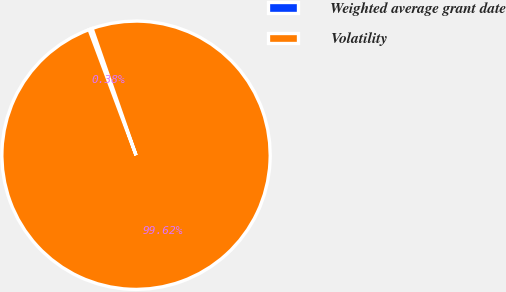<chart> <loc_0><loc_0><loc_500><loc_500><pie_chart><fcel>Weighted average grant date<fcel>Volatility<nl><fcel>0.38%<fcel>99.62%<nl></chart> 